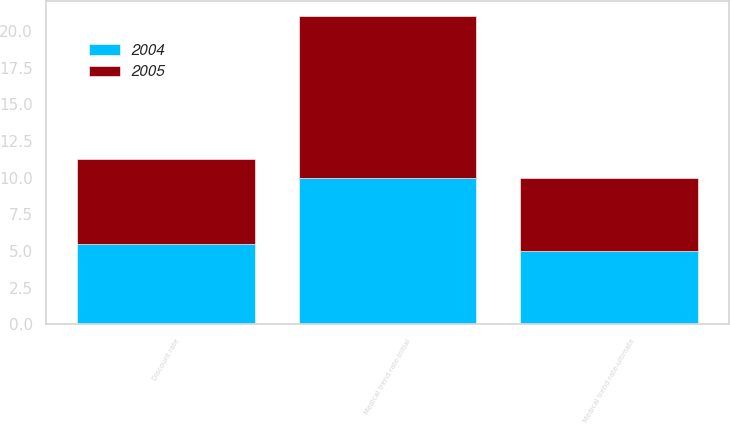Convert chart to OTSL. <chart><loc_0><loc_0><loc_500><loc_500><stacked_bar_chart><ecel><fcel>Discount rate<fcel>Medical trend rate-initial<fcel>Medical trend rate-ultimate<nl><fcel>2004<fcel>5.5<fcel>10<fcel>5<nl><fcel>2005<fcel>5.75<fcel>11<fcel>5<nl></chart> 